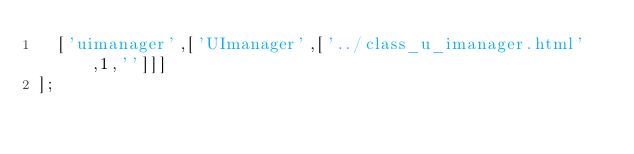Convert code to text. <code><loc_0><loc_0><loc_500><loc_500><_JavaScript_>  ['uimanager',['UImanager',['../class_u_imanager.html',1,'']]]
];
</code> 